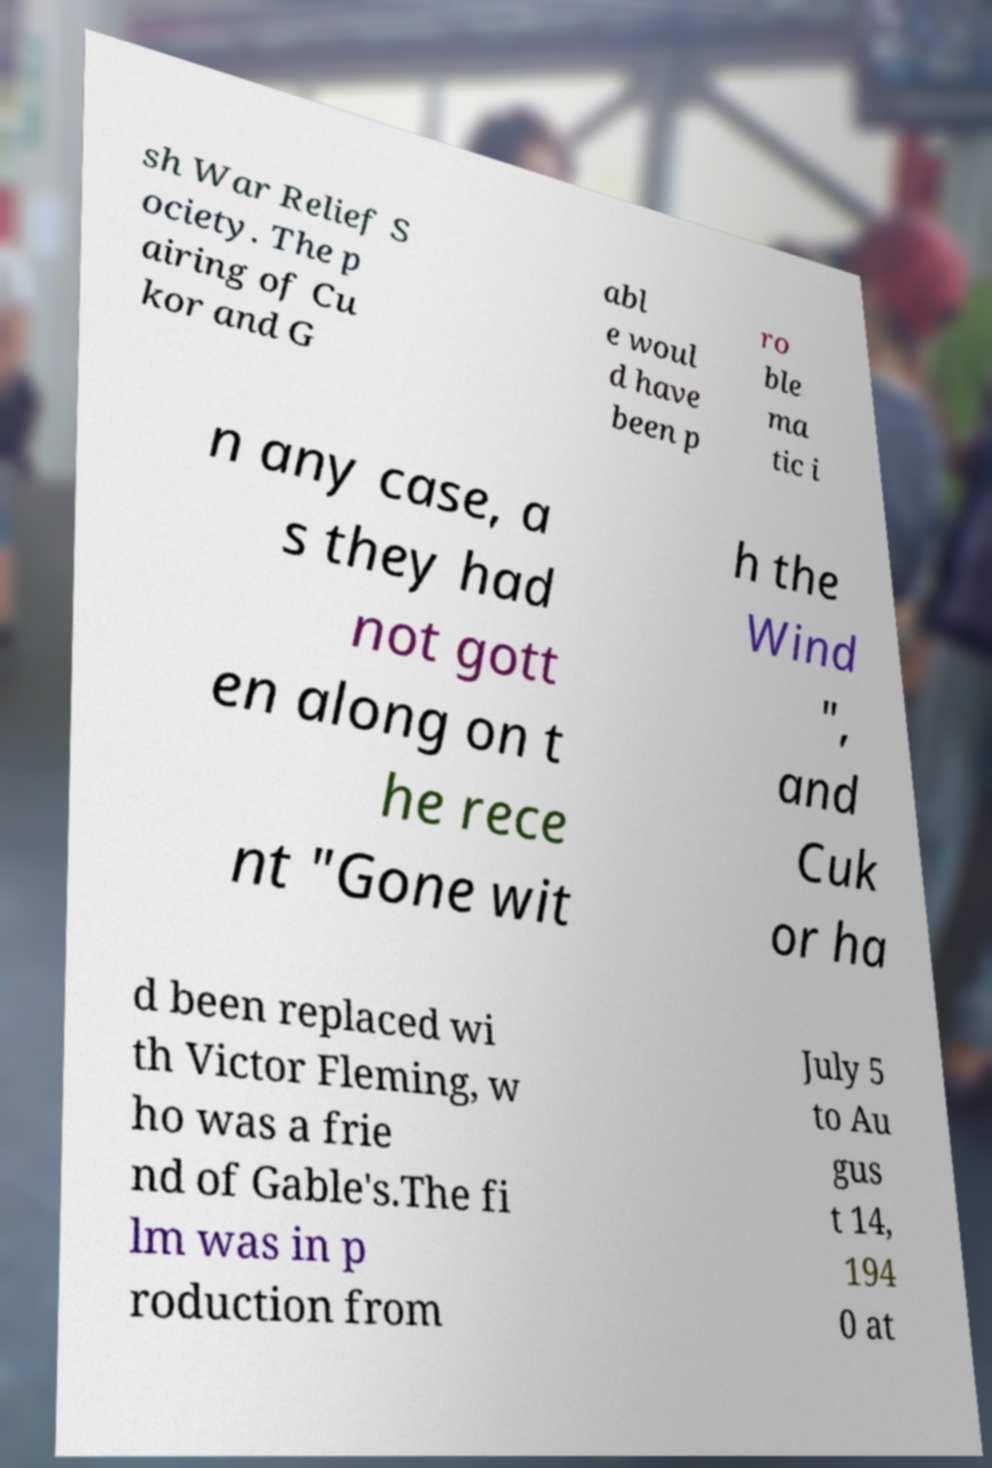For documentation purposes, I need the text within this image transcribed. Could you provide that? sh War Relief S ociety. The p airing of Cu kor and G abl e woul d have been p ro ble ma tic i n any case, a s they had not gott en along on t he rece nt "Gone wit h the Wind ", and Cuk or ha d been replaced wi th Victor Fleming, w ho was a frie nd of Gable's.The fi lm was in p roduction from July 5 to Au gus t 14, 194 0 at 